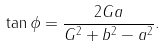<formula> <loc_0><loc_0><loc_500><loc_500>\tan \phi = \frac { 2 G a } { G ^ { 2 } + b ^ { 2 } - a ^ { 2 } } .</formula> 